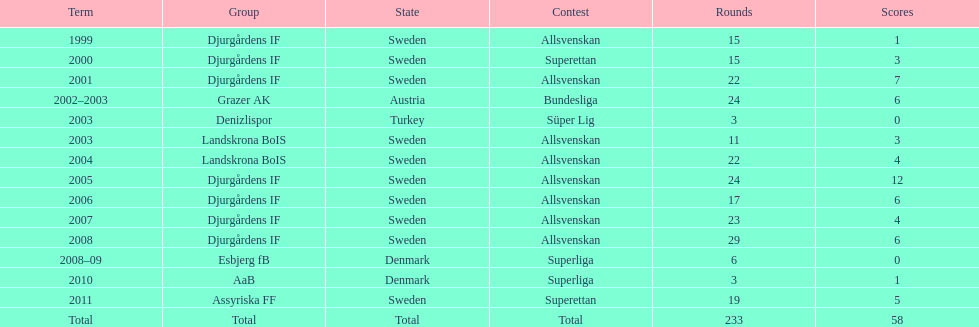How many matches did jones kusi-asare play in in his first season? 15. 